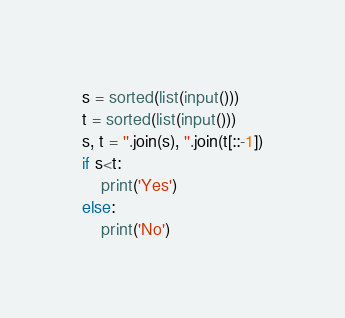Convert code to text. <code><loc_0><loc_0><loc_500><loc_500><_Python_>s = sorted(list(input()))
t = sorted(list(input()))
s, t = ''.join(s), ''.join(t[::-1])
if s<t:
    print('Yes')
else:
    print('No')</code> 